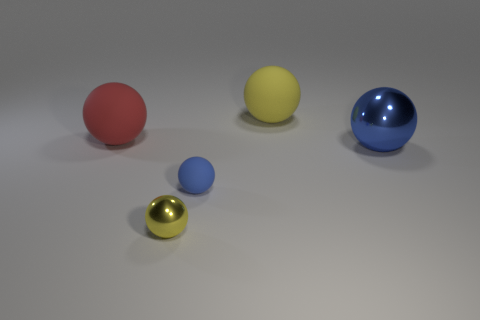Do the big metallic object and the matte ball in front of the large shiny thing have the same color?
Give a very brief answer. Yes. There is a small ball that is behind the small metal ball; what is it made of?
Your response must be concise. Rubber. There is a metallic thing that is the same size as the red matte thing; what shape is it?
Make the answer very short. Sphere. Are there any large blue metal things of the same shape as the big red object?
Provide a short and direct response. Yes. Are the large red ball and the blue sphere to the right of the large yellow thing made of the same material?
Your response must be concise. No. The yellow object that is in front of the big blue sphere that is in front of the yellow matte thing is made of what material?
Offer a terse response. Metal. Are there more big metal objects on the right side of the large yellow sphere than tiny green rubber spheres?
Your answer should be compact. Yes. Are there any blue matte cylinders?
Your answer should be very brief. No. There is a big matte thing left of the yellow rubber sphere; what color is it?
Offer a terse response. Red. What is the material of the other object that is the same size as the yellow metal object?
Your answer should be very brief. Rubber. 